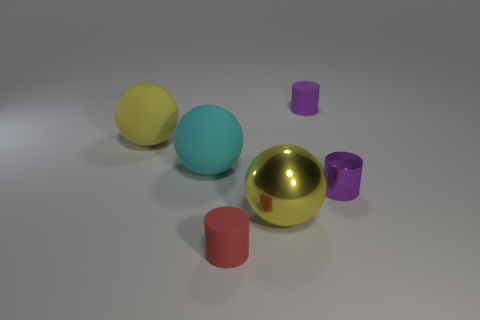There is a yellow sphere that is the same size as the yellow matte object; what is its material?
Provide a short and direct response. Metal. How many other objects are there of the same material as the big cyan object?
Provide a succinct answer. 3. There is a small rubber cylinder that is behind the large cyan matte object; does it have the same color as the metallic object behind the big yellow metal object?
Keep it short and to the point. Yes. What is the shape of the tiny rubber thing that is to the right of the big sphere in front of the big cyan rubber object?
Your answer should be very brief. Cylinder. What number of other objects are the same color as the metal cylinder?
Make the answer very short. 1. Do the cylinder that is to the right of the purple rubber cylinder and the small purple thing behind the big yellow rubber ball have the same material?
Ensure brevity in your answer.  No. How big is the purple thing that is in front of the yellow matte sphere?
Offer a terse response. Small. What is the material of the other large yellow thing that is the same shape as the yellow rubber object?
Provide a succinct answer. Metal. What is the shape of the rubber thing right of the red thing?
Offer a very short reply. Cylinder. What number of purple matte things have the same shape as the small red object?
Your answer should be compact. 1. 